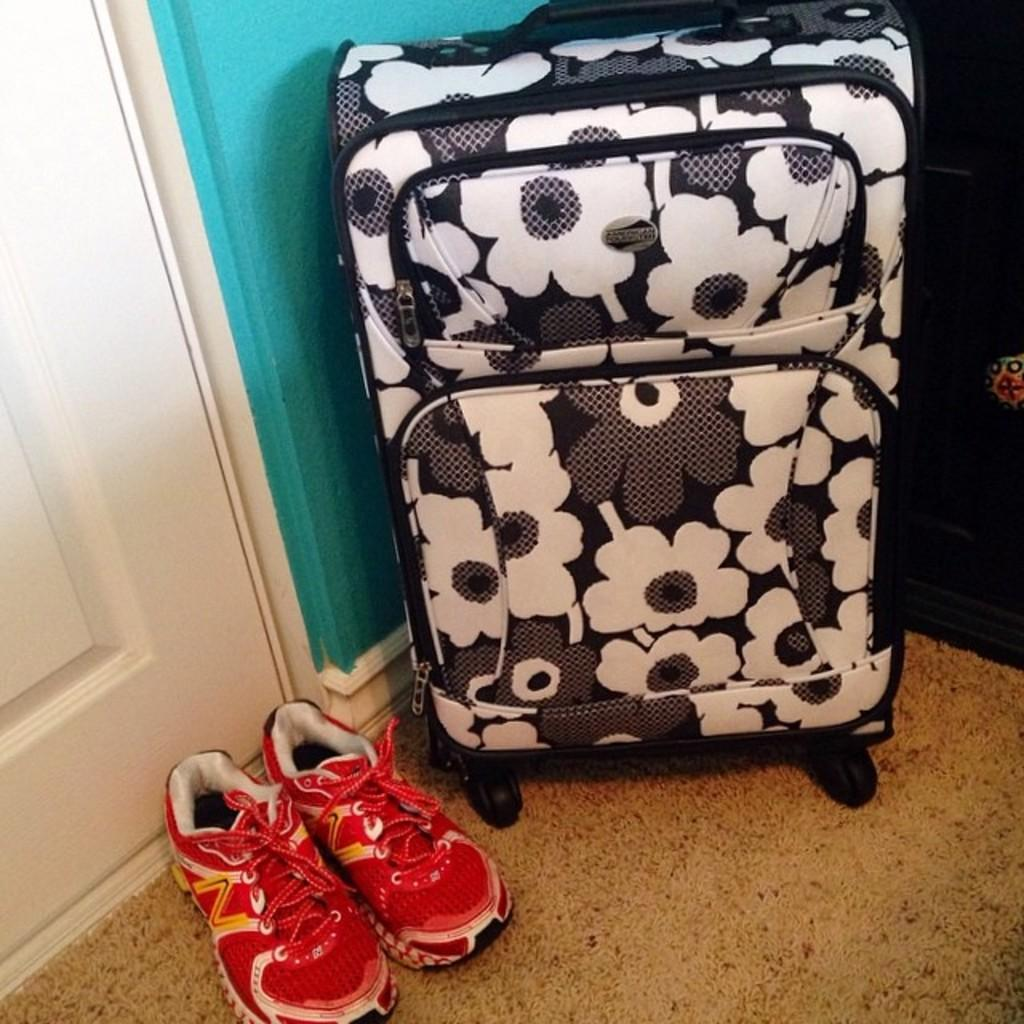What type of trolley is in the image? There is a black and white trolley in the image. What color are the shoes in the image? The shoes in the image are red. What can be used to enter or exit a room in the image? There is a door in the image. What can be used to separate rooms or provide support in the image? There is a wall in the image. How many cracks can be seen on the trolley in the image? There are no cracks visible on the trolley in the image. What type of blade is being used to cut the shoes in the image? There is no blade present in the image, and the shoes are not being cut. 